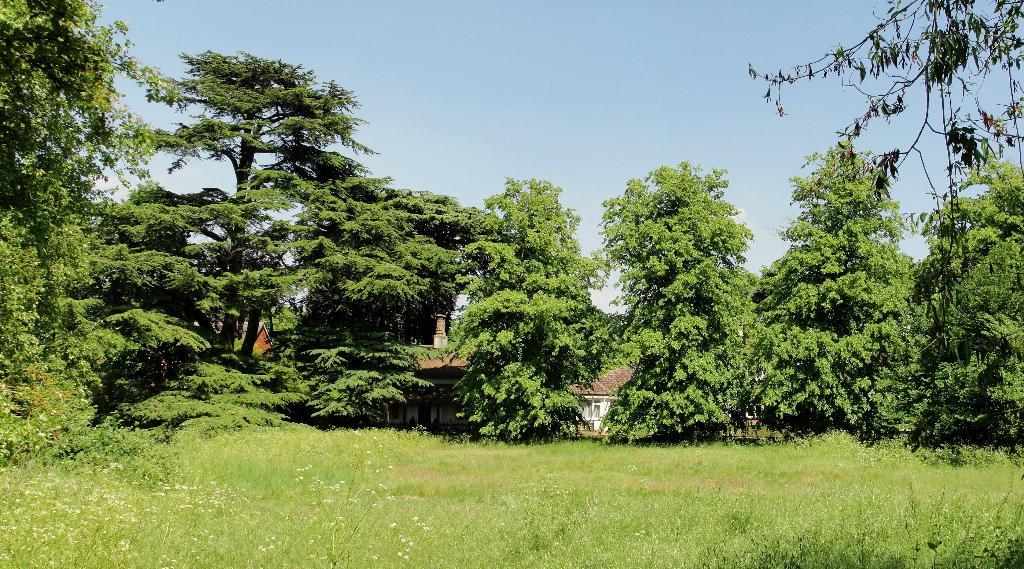What type of landscape is visible at the bottom of the image? There is grassland at the bottom side of the image. What can be seen in the center of the image? There are trees in the center of the image. What type of structures are visible in the background of the image? There are houses in the background area of the image. Is there a birthday celebration happening in the image? There is no indication of a birthday celebration in the image. Can you see any family members in the image? The image does not show any family members. 